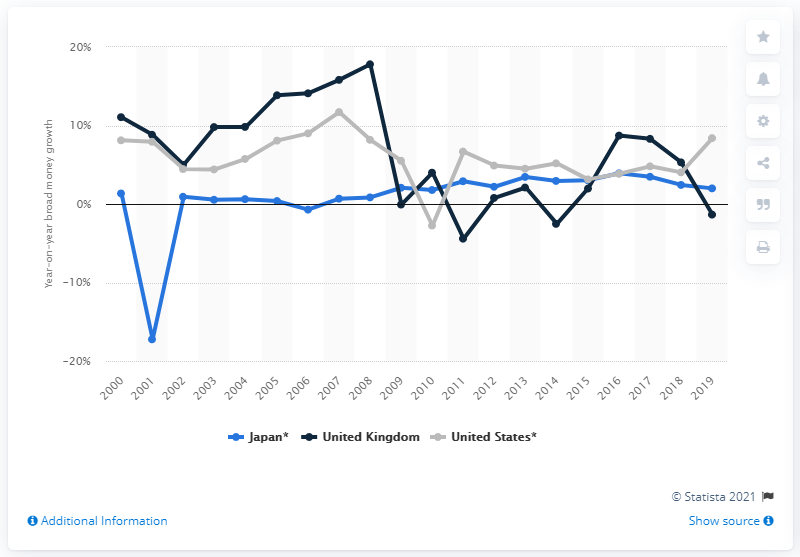Give some essential details in this illustration. The broad money growth rate in the UK in 2018 was 5.3%. The broad money supply in the United States in 2019 was 8.39. 